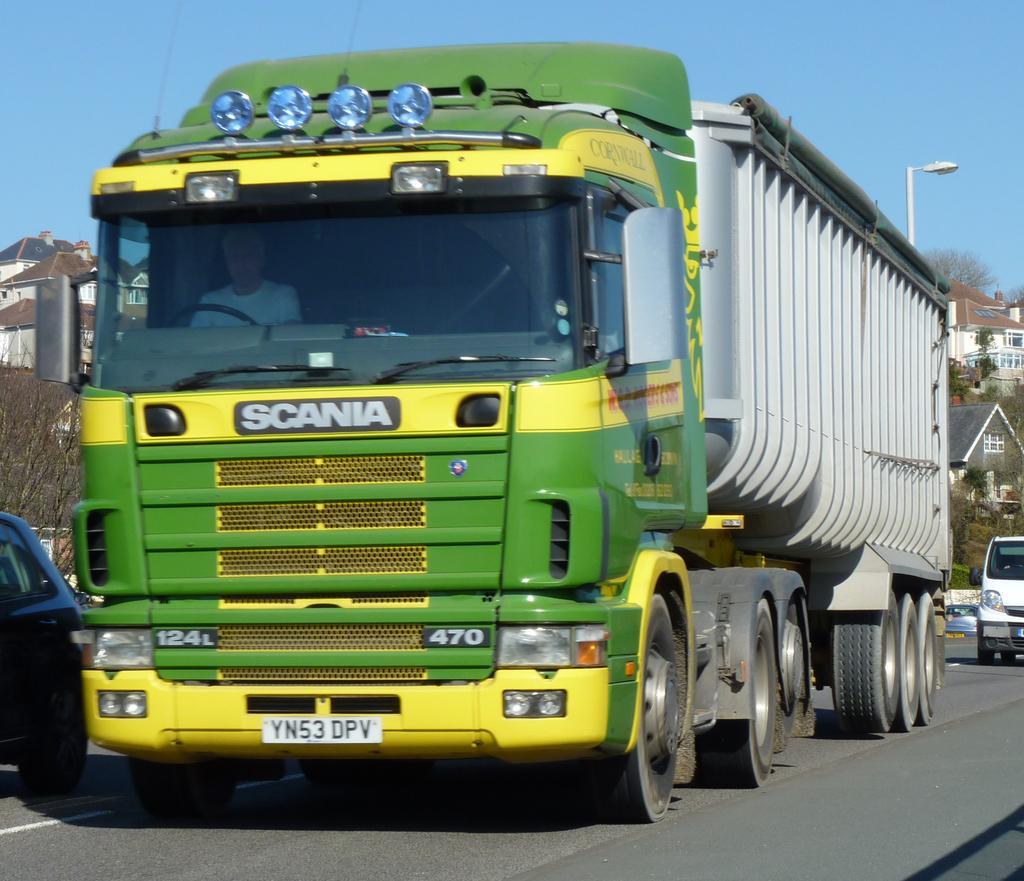Describe this image in one or two sentences. In the middle of this image, there is a lorry on a road, on which there are other vehicles and white color lines. In the background, there are trees, buildings, a pole and there are clouds in the blue sky. 